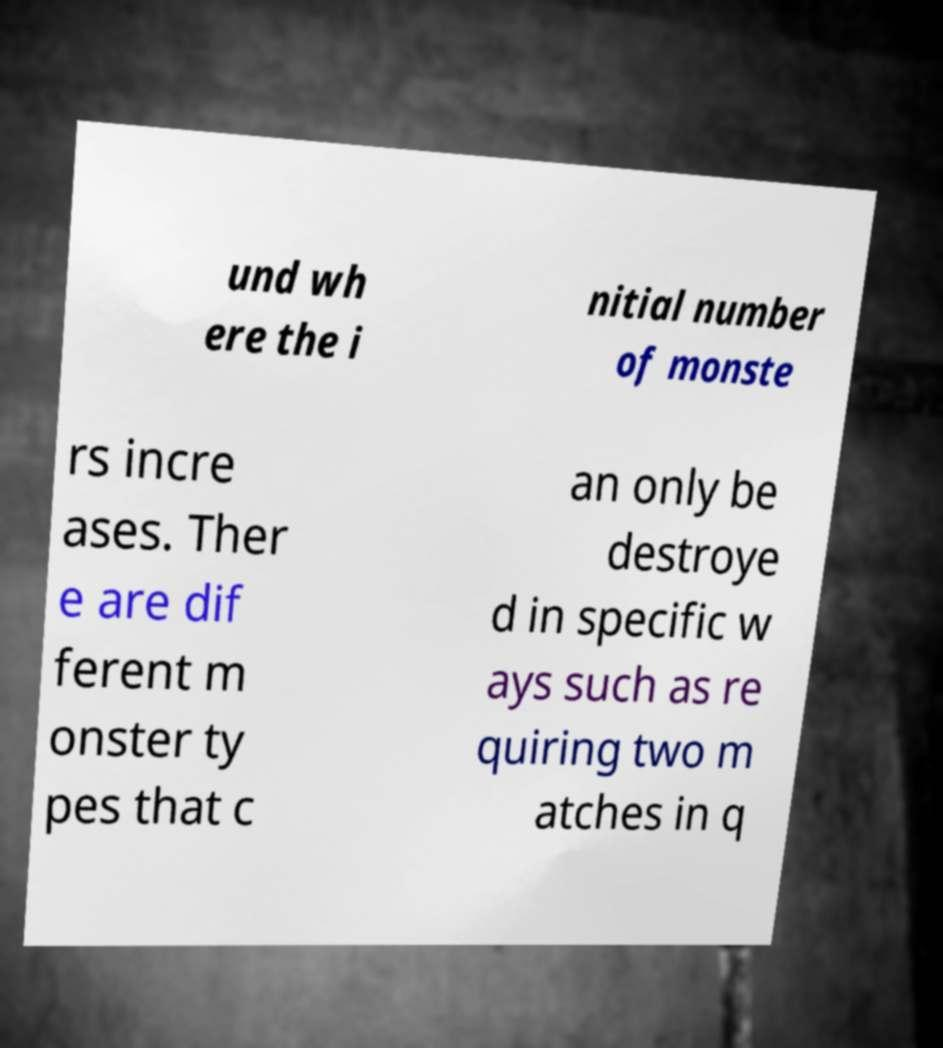Could you assist in decoding the text presented in this image and type it out clearly? und wh ere the i nitial number of monste rs incre ases. Ther e are dif ferent m onster ty pes that c an only be destroye d in specific w ays such as re quiring two m atches in q 